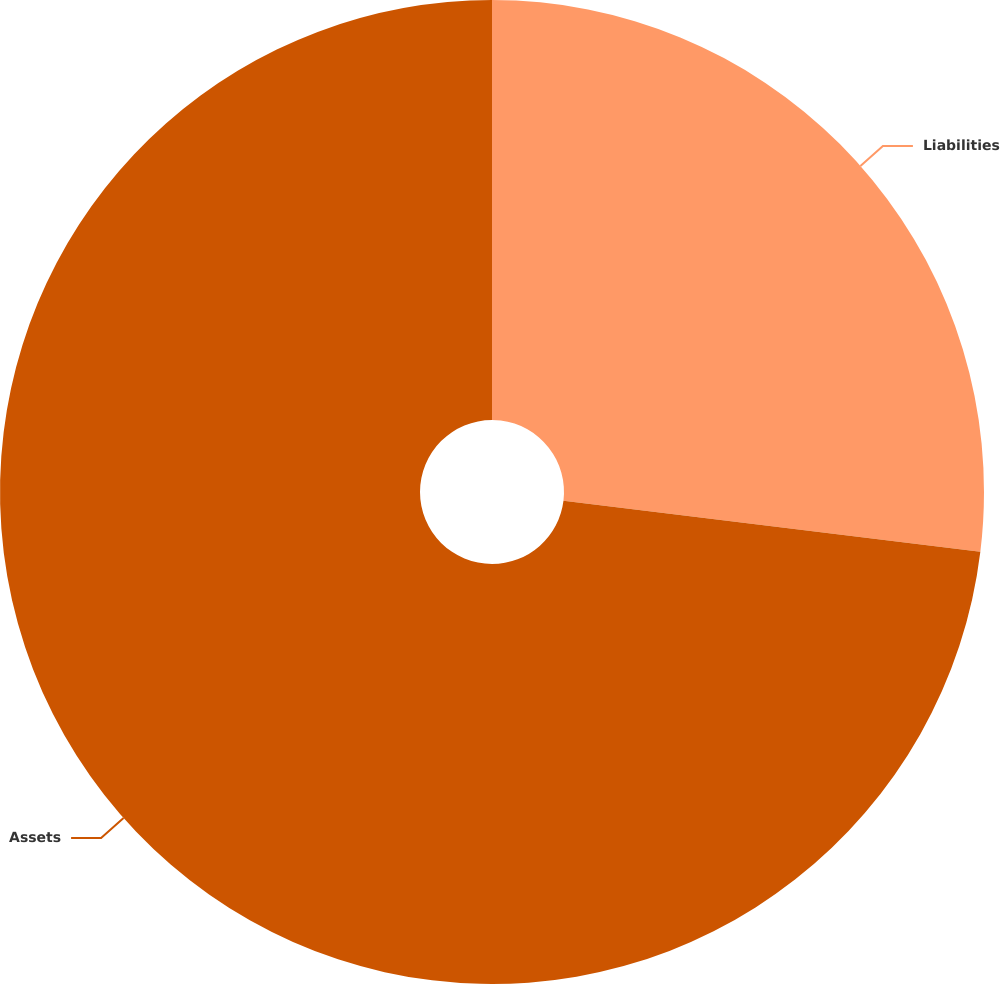Convert chart to OTSL. <chart><loc_0><loc_0><loc_500><loc_500><pie_chart><fcel>Liabilities<fcel>Assets<nl><fcel>26.94%<fcel>73.06%<nl></chart> 